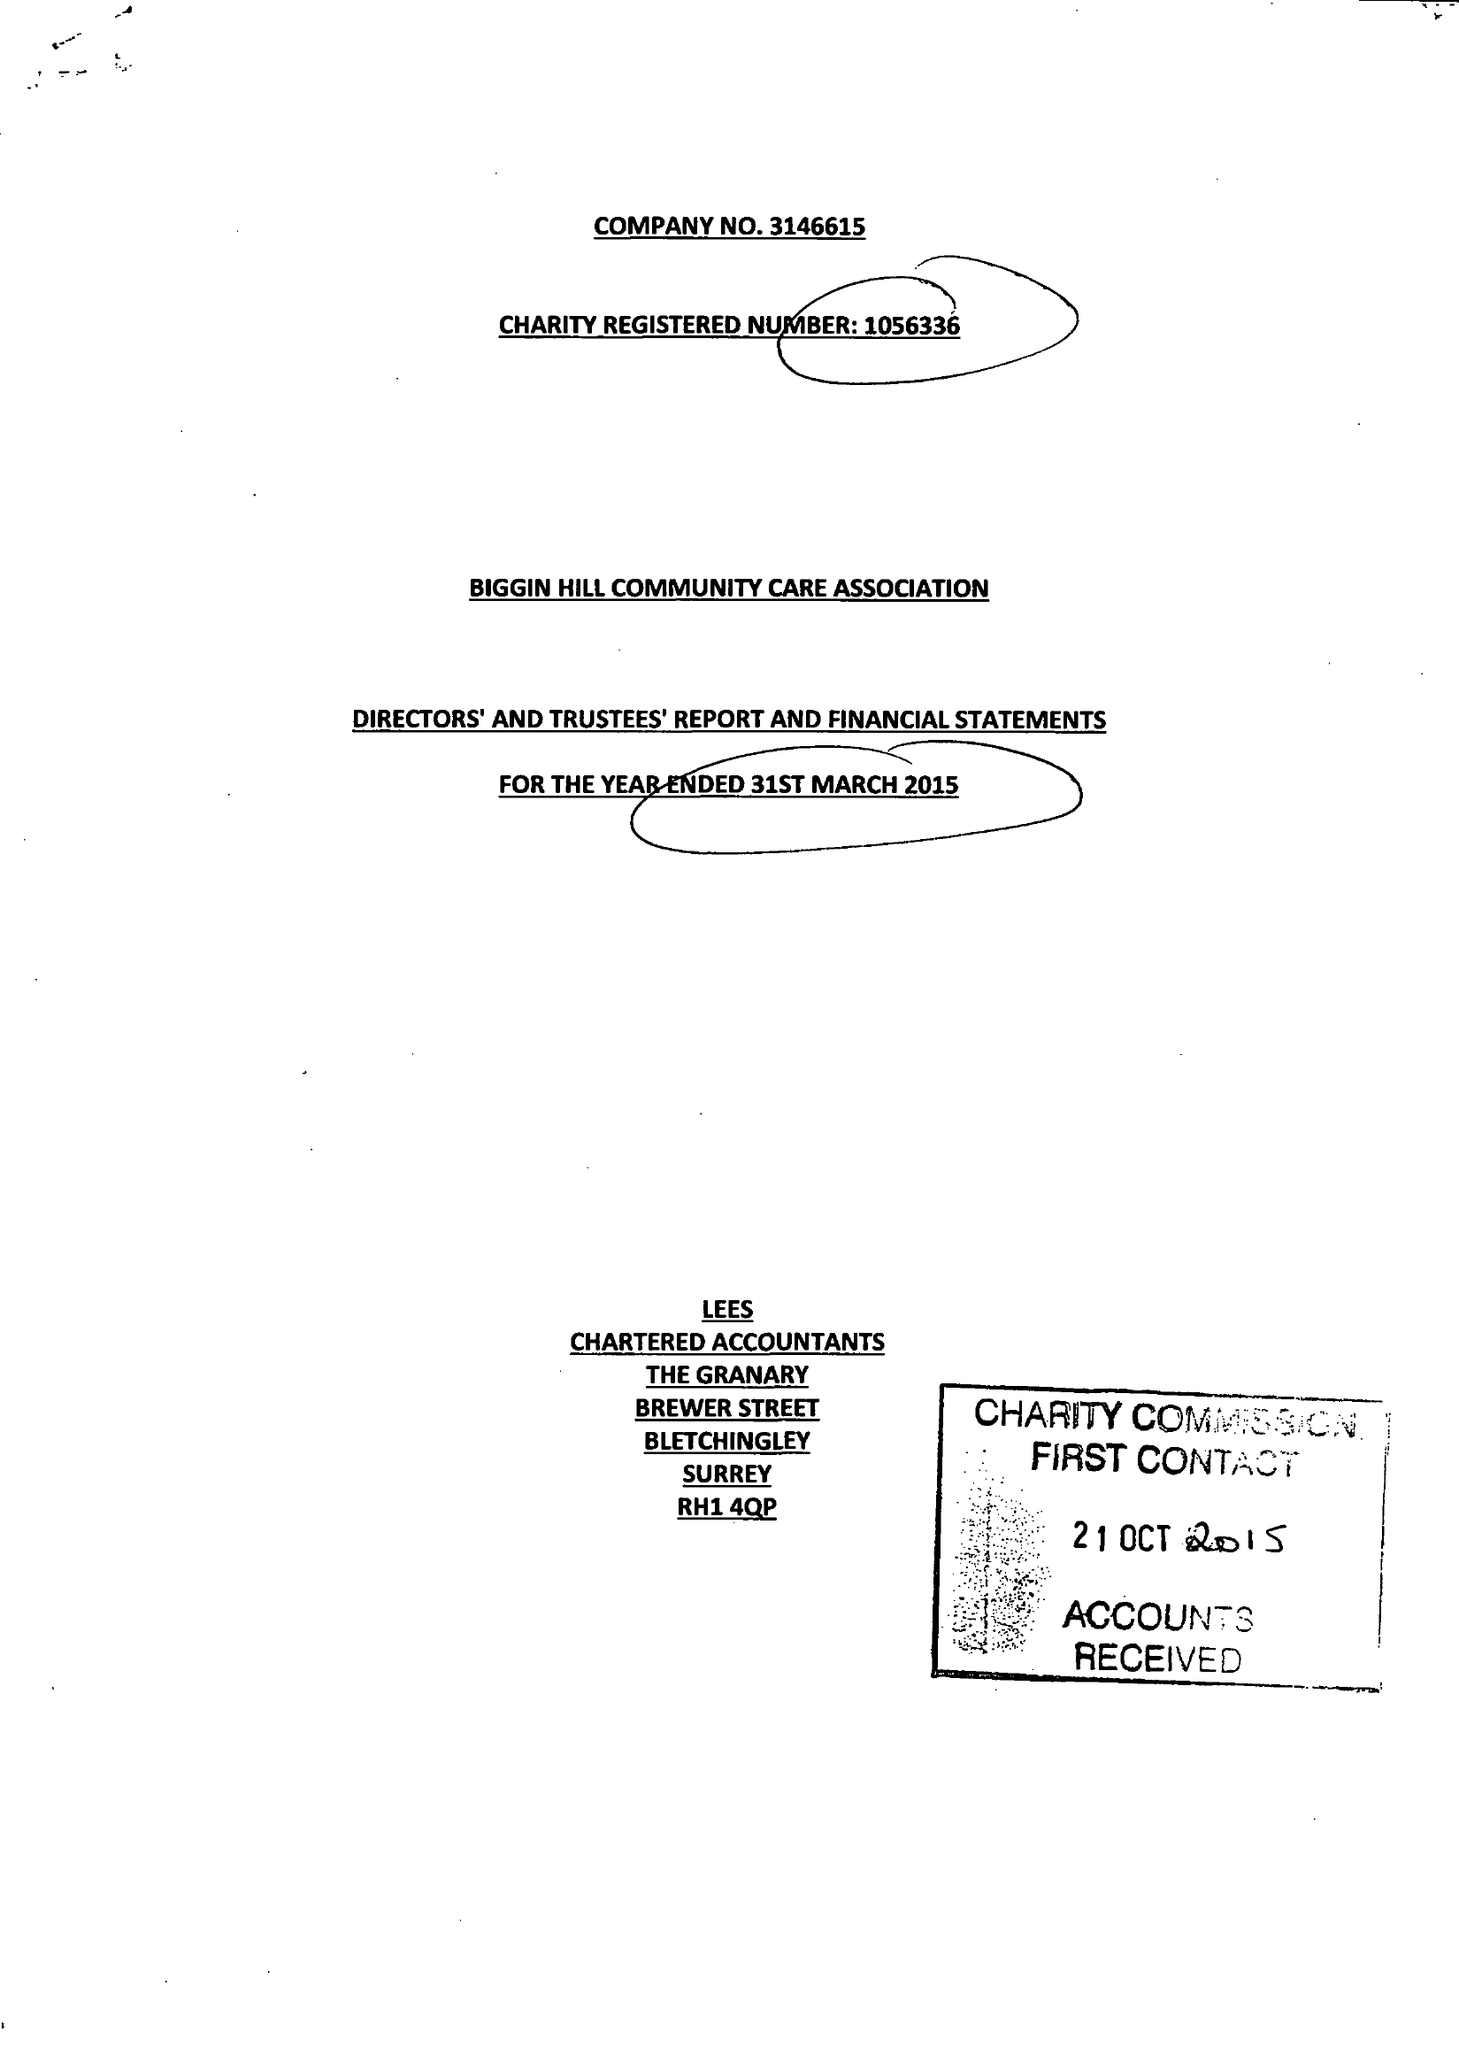What is the value for the income_annually_in_british_pounds?
Answer the question using a single word or phrase. 60343.00 